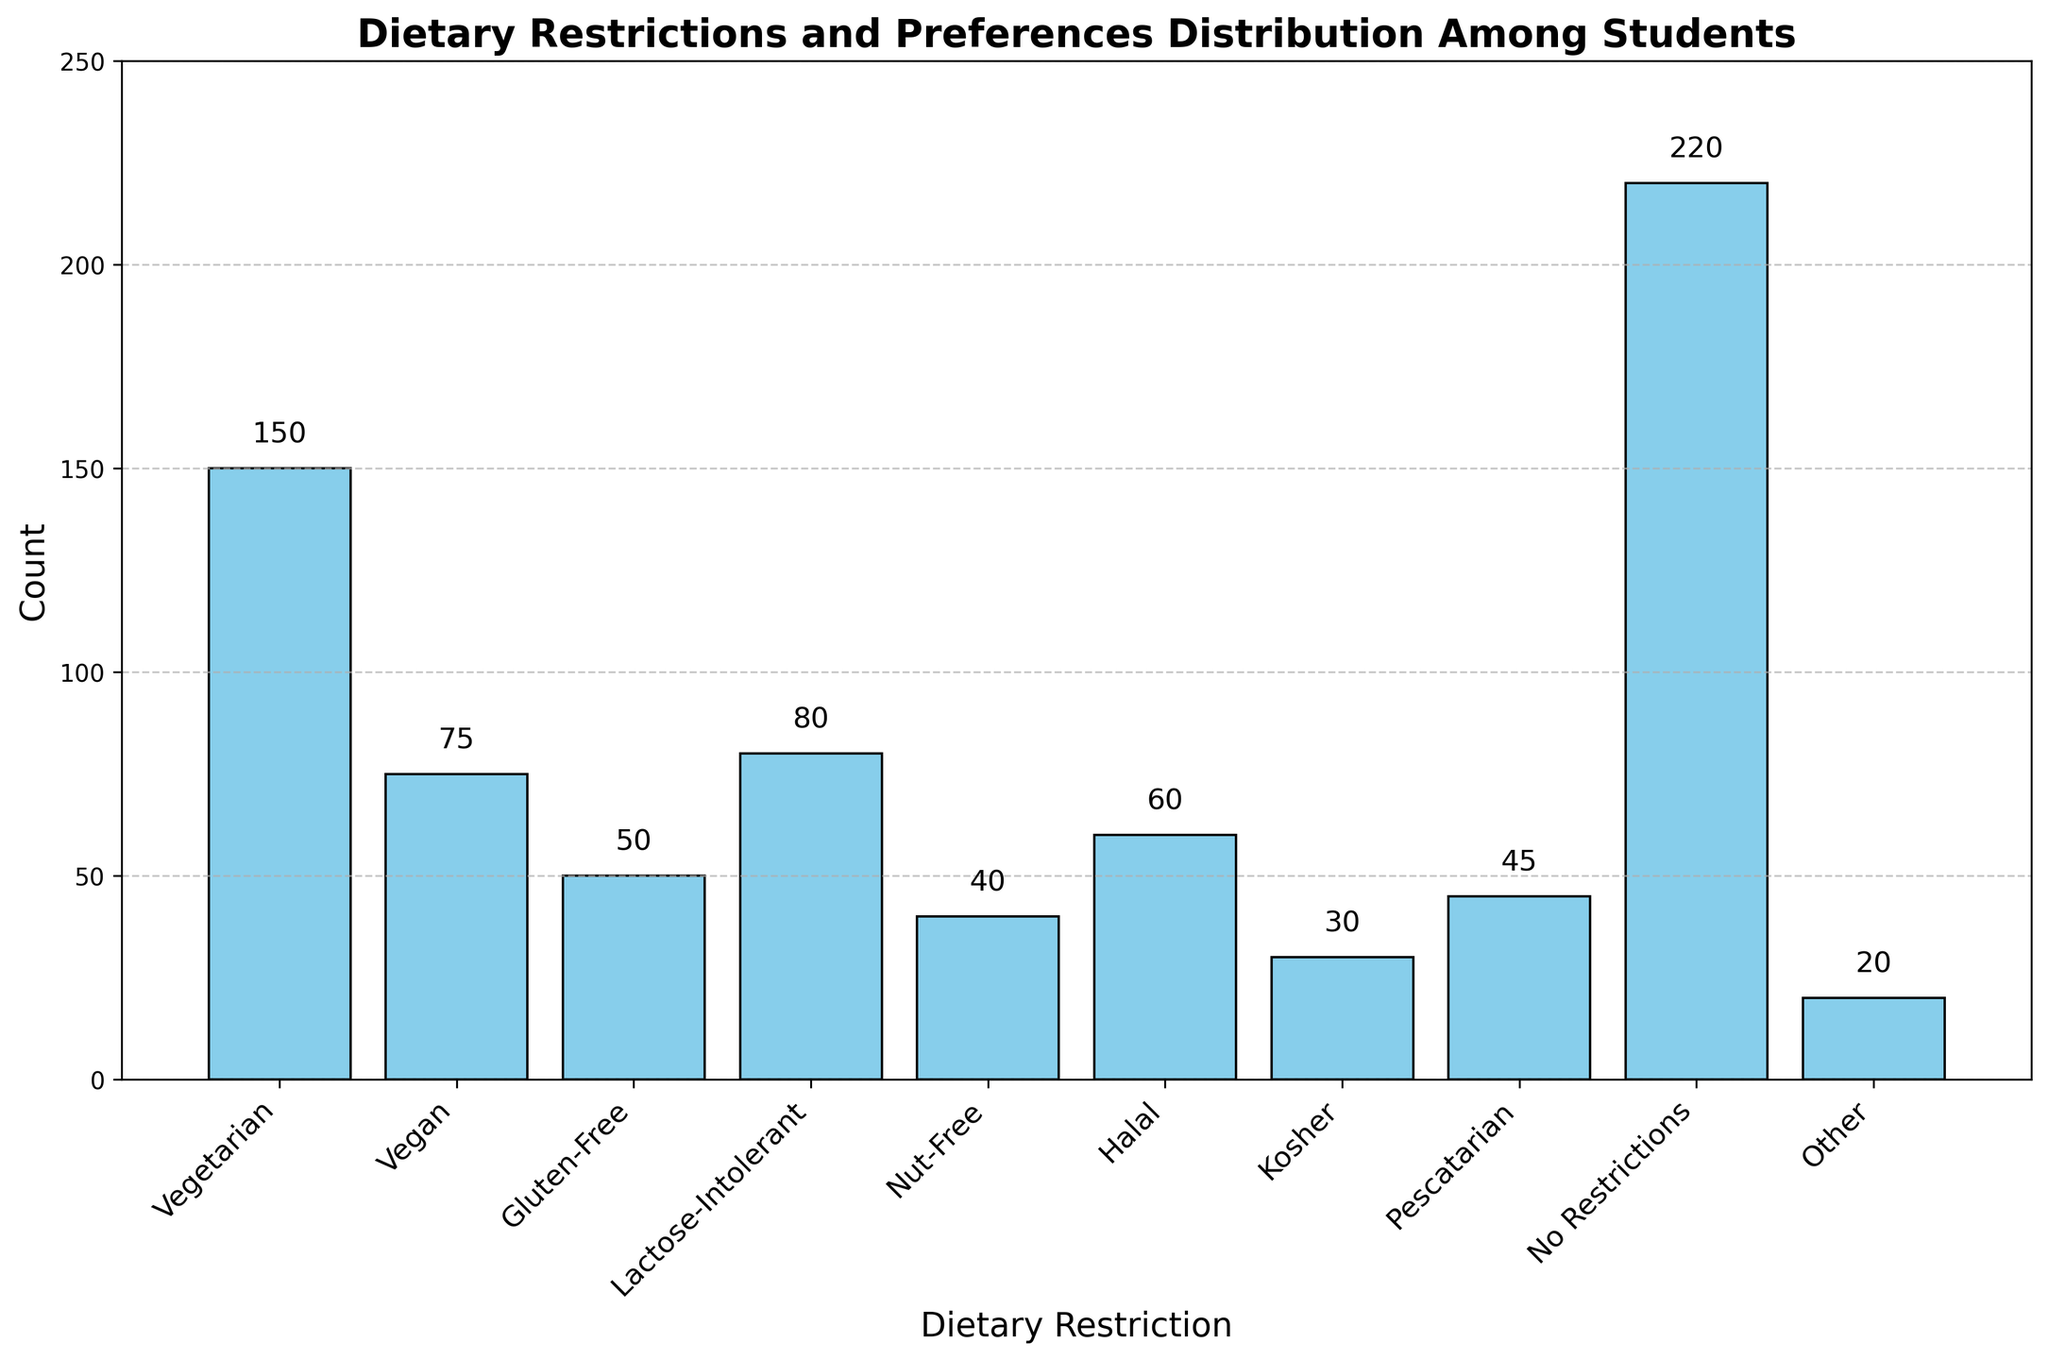What is the total number of students who reported having dietary restrictions? To find the total number of students with dietary restrictions, sum the counts of all dietary restrictions. This includes Vegetarian (150), Vegan (75), Gluten-Free (50), Lactose-Intolerant (80), Nut-Free (40), Halal (60), Kosher (30), Pescatarian (45), No Restrictions (220), and Other (20). Sum = 150 + 75 + 50 + 80 + 40 + 60 + 30 + 45 + 220 + 20 = 770 students.
Answer: 770 Which dietary restriction has the highest count? Examine the bar heights to identify the tallest bar. The "No Restrictions" bar is the tallest, indicating the largest count.
Answer: No Restrictions How does the number of Vegan students compare to the number of Halal students? By looking at the heights of the bars for Vegan and Halal, you can see that the Vegan bar (75) is taller than the Halal bar (60).
Answer: There are more Vegan students What is the difference in the count between Gluten-Free and Lactose-Intolerant students? Subtract the count of Gluten-Free students (50) from the count of Lactose-Intolerant students (80): 80 - 50 = 30.
Answer: 30 What is the combined total of students with Nut-Free and Pescatarian dietary preferences? Add the counts of Nut-Free (40) and Pescatarian (45) students: 40 + 45 = 85.
Answer: 85 How many more Vegetarian students are there compared to Vegan students? Subtract the count of Vegan students (75) from the count of Vegetarian students (150): 150 - 75 = 75.
Answer: 75 Which dietary restriction has the lowest count and what is that count? Identify the shortest bar in the graph. The "Other" bar is the shortest, with a count of 20.
Answer: Other, 20 How many students reported being Kosher, and what percentage of the total reporting does this represent? Kosher students count is 30. The total number of students is 770. The percentage is calculated as (30 / 770) * 100 ≈ 3.90%.
Answer: 30, 3.90% Are there more students with No Restrictions or combined students of Vegetarian and Vegan preferences? Compare the count of students with No Restrictions (220) to the sum of Vegetarian (150) and Vegan (75) students: 220 versus 150 + 75 = 225.
Answer: Combined Vegetarian and Vegan What is the sum of counts for all dietary restrictions other than "No Restrictions"? Exclude the count for "No Restrictions" (220) and sum the remaining categories: 150 + 75 + 50 + 80 + 40 + 60 + 30 + 45 + 20 = 550.
Answer: 550 